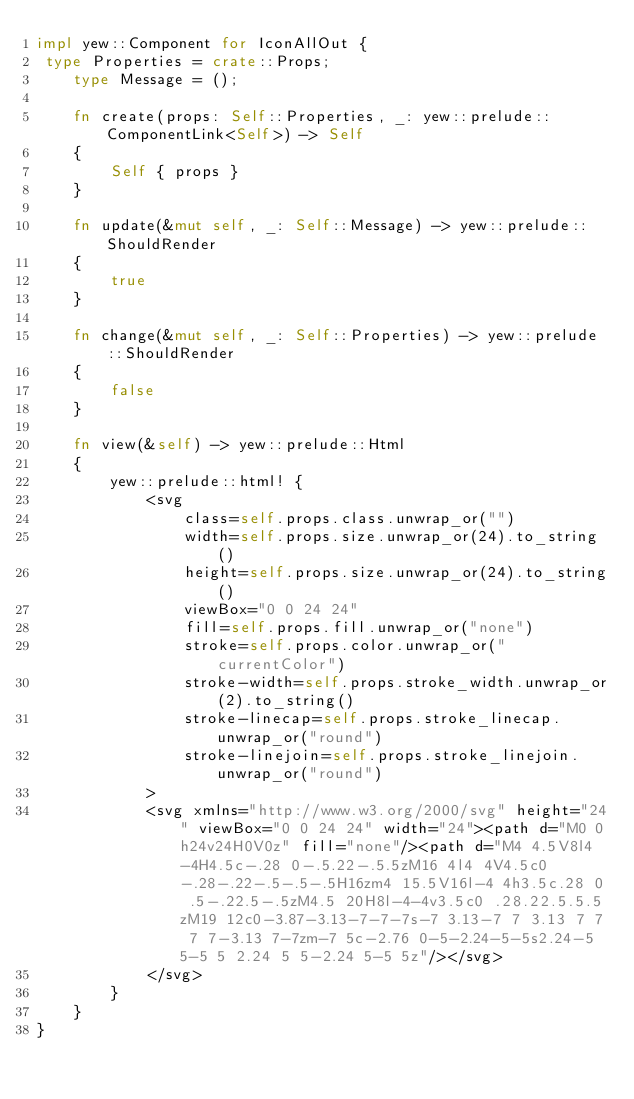Convert code to text. <code><loc_0><loc_0><loc_500><loc_500><_Rust_>impl yew::Component for IconAllOut {
 type Properties = crate::Props;
    type Message = ();

    fn create(props: Self::Properties, _: yew::prelude::ComponentLink<Self>) -> Self
    {
        Self { props }
    }

    fn update(&mut self, _: Self::Message) -> yew::prelude::ShouldRender
    {
        true
    }

    fn change(&mut self, _: Self::Properties) -> yew::prelude::ShouldRender
    {
        false
    }

    fn view(&self) -> yew::prelude::Html
    {
        yew::prelude::html! {
            <svg
                class=self.props.class.unwrap_or("")
                width=self.props.size.unwrap_or(24).to_string()
                height=self.props.size.unwrap_or(24).to_string()
                viewBox="0 0 24 24"
                fill=self.props.fill.unwrap_or("none")
                stroke=self.props.color.unwrap_or("currentColor")
                stroke-width=self.props.stroke_width.unwrap_or(2).to_string()
                stroke-linecap=self.props.stroke_linecap.unwrap_or("round")
                stroke-linejoin=self.props.stroke_linejoin.unwrap_or("round")
            >
            <svg xmlns="http://www.w3.org/2000/svg" height="24" viewBox="0 0 24 24" width="24"><path d="M0 0h24v24H0V0z" fill="none"/><path d="M4 4.5V8l4-4H4.5c-.28 0-.5.22-.5.5zM16 4l4 4V4.5c0-.28-.22-.5-.5-.5H16zm4 15.5V16l-4 4h3.5c.28 0 .5-.22.5-.5zM4.5 20H8l-4-4v3.5c0 .28.22.5.5.5zM19 12c0-3.87-3.13-7-7-7s-7 3.13-7 7 3.13 7 7 7 7-3.13 7-7zm-7 5c-2.76 0-5-2.24-5-5s2.24-5 5-5 5 2.24 5 5-2.24 5-5 5z"/></svg>
            </svg>
        }
    }
}


</code> 